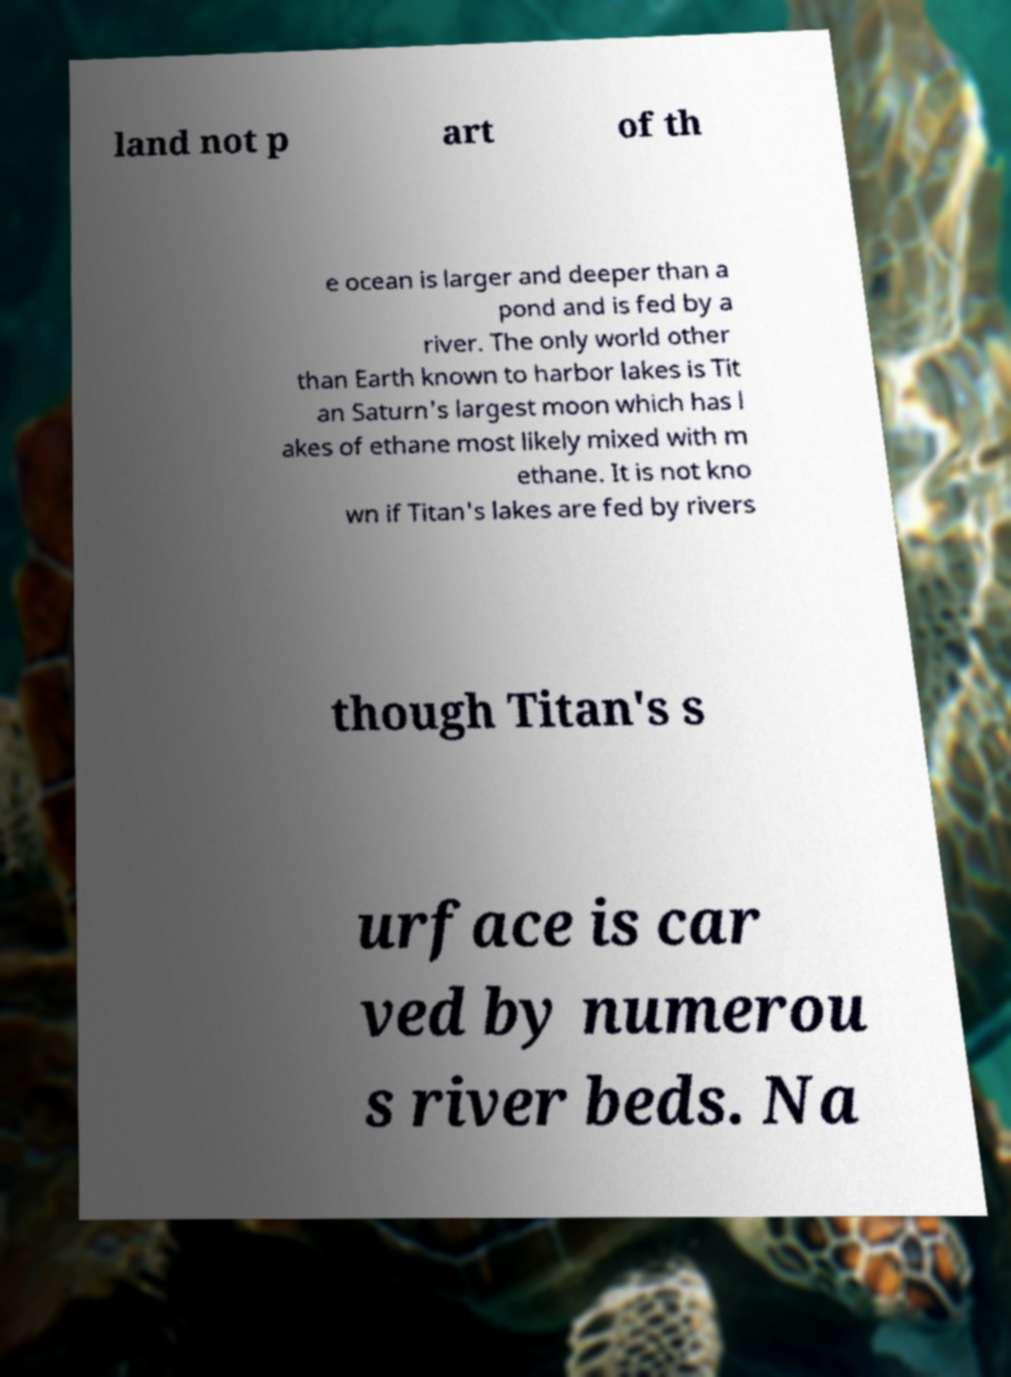Please read and relay the text visible in this image. What does it say? land not p art of th e ocean is larger and deeper than a pond and is fed by a river. The only world other than Earth known to harbor lakes is Tit an Saturn's largest moon which has l akes of ethane most likely mixed with m ethane. It is not kno wn if Titan's lakes are fed by rivers though Titan's s urface is car ved by numerou s river beds. Na 